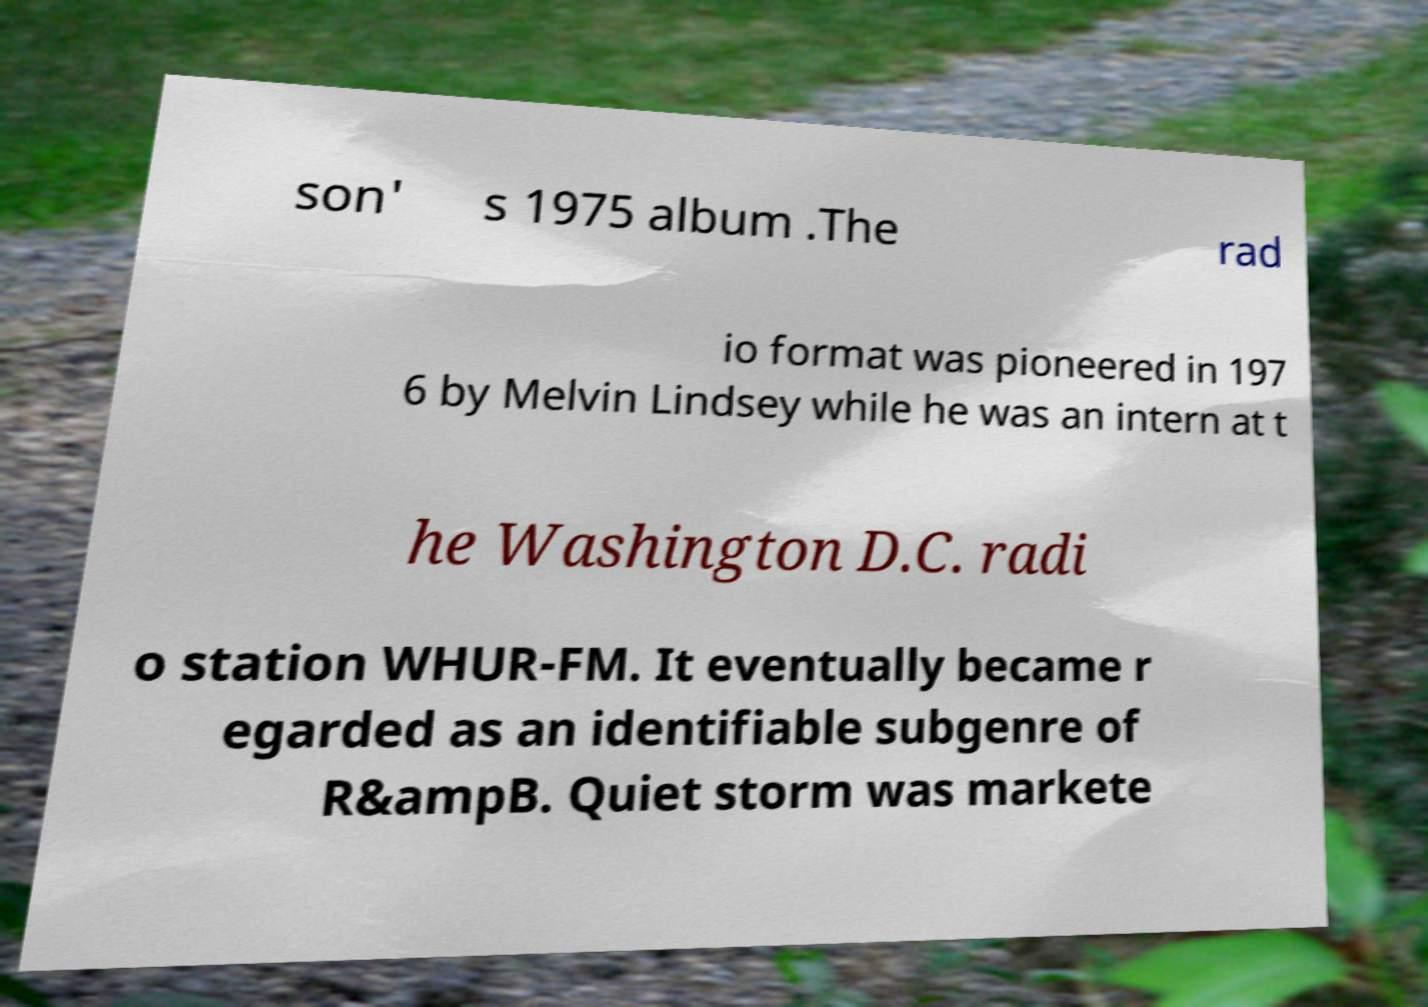I need the written content from this picture converted into text. Can you do that? son' s 1975 album .The rad io format was pioneered in 197 6 by Melvin Lindsey while he was an intern at t he Washington D.C. radi o station WHUR-FM. It eventually became r egarded as an identifiable subgenre of R&ampB. Quiet storm was markete 